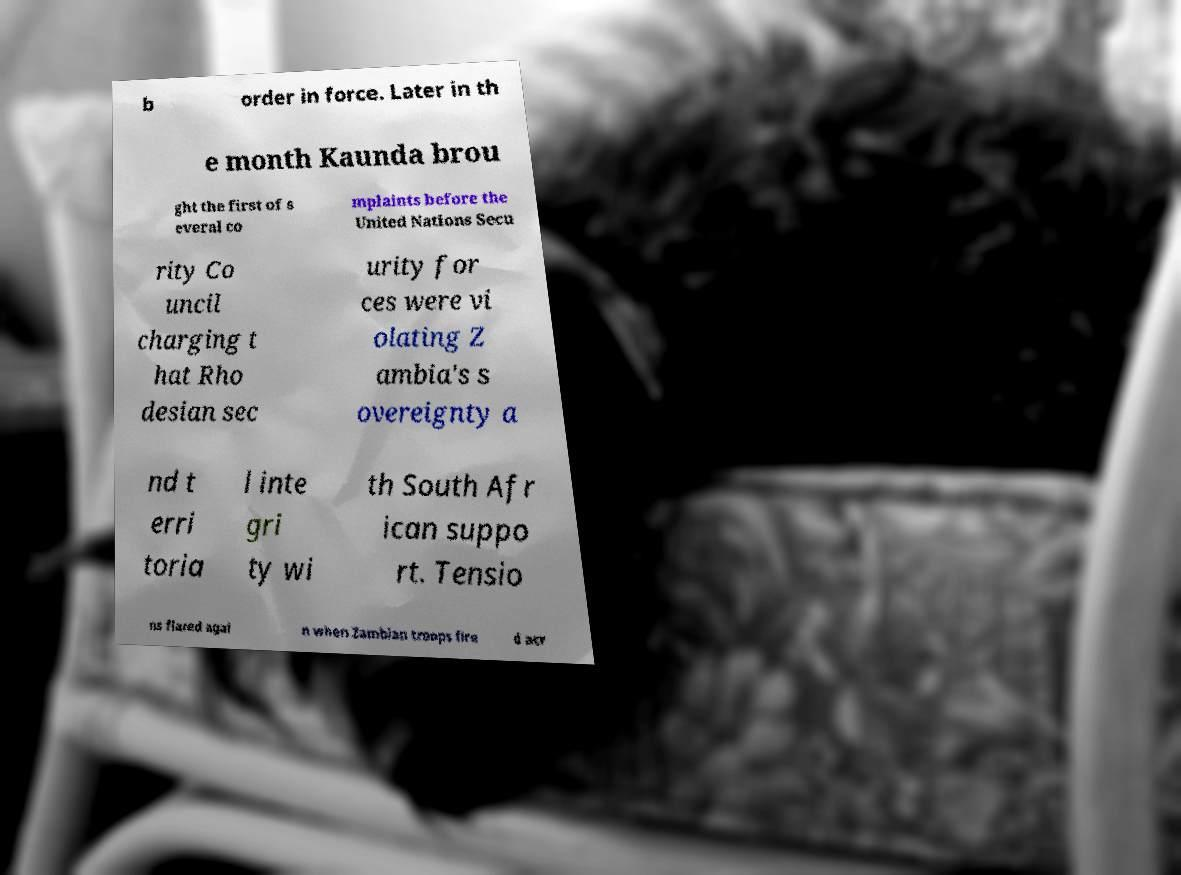For documentation purposes, I need the text within this image transcribed. Could you provide that? b order in force. Later in th e month Kaunda brou ght the first of s everal co mplaints before the United Nations Secu rity Co uncil charging t hat Rho desian sec urity for ces were vi olating Z ambia's s overeignty a nd t erri toria l inte gri ty wi th South Afr ican suppo rt. Tensio ns flared agai n when Zambian troops fire d acr 